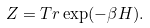Convert formula to latex. <formula><loc_0><loc_0><loc_500><loc_500>Z = T r \exp ( - \beta H ) .</formula> 